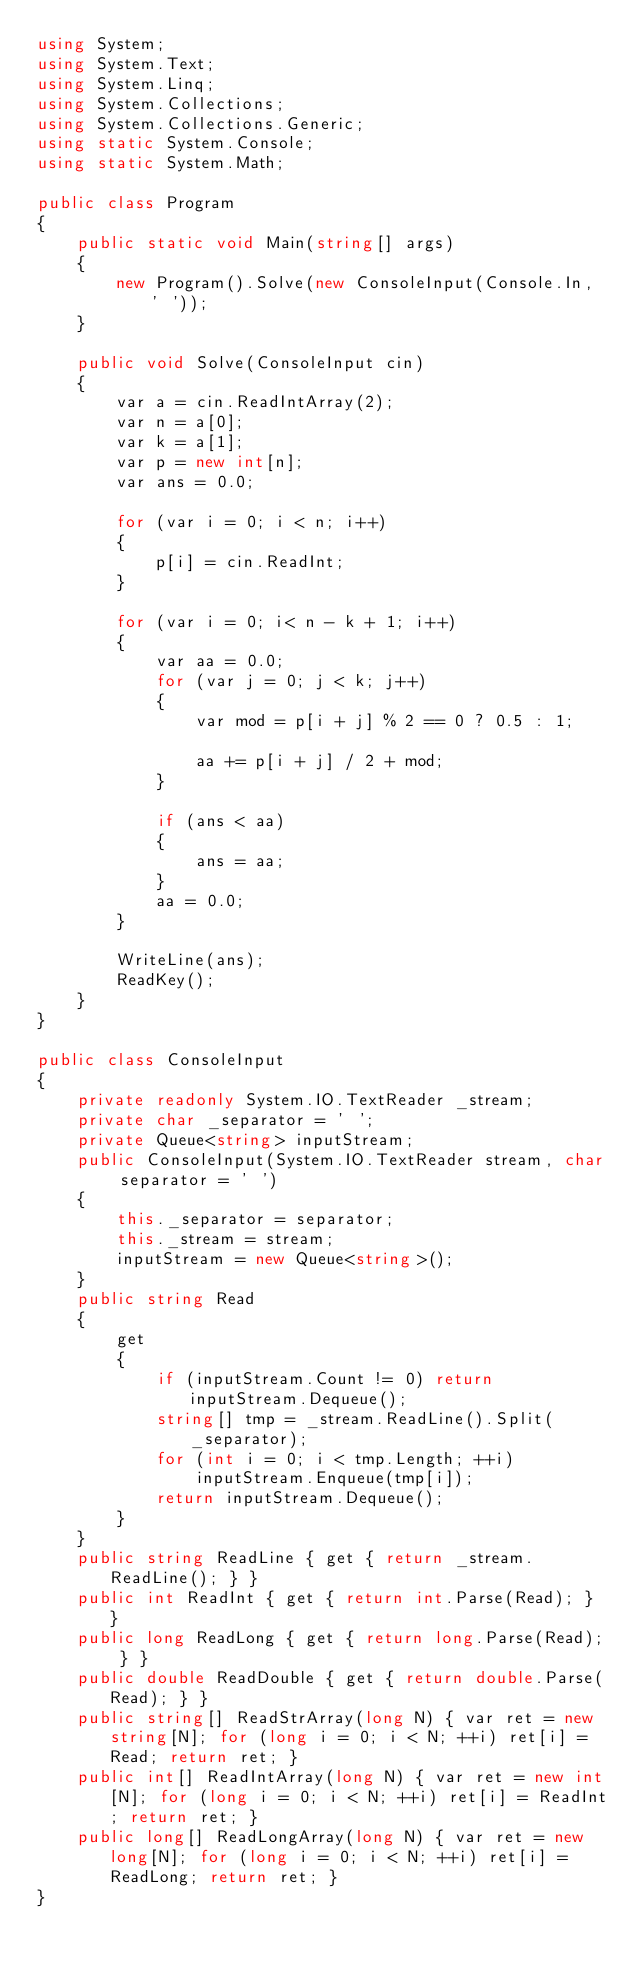<code> <loc_0><loc_0><loc_500><loc_500><_C#_>using System;
using System.Text;
using System.Linq;
using System.Collections;
using System.Collections.Generic;
using static System.Console;
using static System.Math;

public class Program
{
    public static void Main(string[] args)
    {
        new Program().Solve(new ConsoleInput(Console.In, ' '));
    }

    public void Solve(ConsoleInput cin)
    {
        var a = cin.ReadIntArray(2);
        var n = a[0];
        var k = a[1];
        var p = new int[n];
        var ans = 0.0;

        for (var i = 0; i < n; i++)
        {
            p[i] = cin.ReadInt;
        }

        for (var i = 0; i< n - k + 1; i++)
        {
            var aa = 0.0;
            for (var j = 0; j < k; j++)
            {
                var mod = p[i + j] % 2 == 0 ? 0.5 : 1;

                aa += p[i + j] / 2 + mod;
            }

            if (ans < aa)
            {
                ans = aa;
            }
            aa = 0.0;
        }

        WriteLine(ans);
        ReadKey();
    }
}

public class ConsoleInput
{
    private readonly System.IO.TextReader _stream;
    private char _separator = ' ';
    private Queue<string> inputStream;
    public ConsoleInput(System.IO.TextReader stream, char separator = ' ')
    {
        this._separator = separator;
        this._stream = stream;
        inputStream = new Queue<string>();
    }
    public string Read
    {
        get
        {
            if (inputStream.Count != 0) return inputStream.Dequeue();
            string[] tmp = _stream.ReadLine().Split(_separator);
            for (int i = 0; i < tmp.Length; ++i)
                inputStream.Enqueue(tmp[i]);
            return inputStream.Dequeue();
        }
    }
    public string ReadLine { get { return _stream.ReadLine(); } }
    public int ReadInt { get { return int.Parse(Read); } }
    public long ReadLong { get { return long.Parse(Read); } }
    public double ReadDouble { get { return double.Parse(Read); } }
    public string[] ReadStrArray(long N) { var ret = new string[N]; for (long i = 0; i < N; ++i) ret[i] = Read; return ret; }
    public int[] ReadIntArray(long N) { var ret = new int[N]; for (long i = 0; i < N; ++i) ret[i] = ReadInt; return ret; }
    public long[] ReadLongArray(long N) { var ret = new long[N]; for (long i = 0; i < N; ++i) ret[i] = ReadLong; return ret; }
}
</code> 